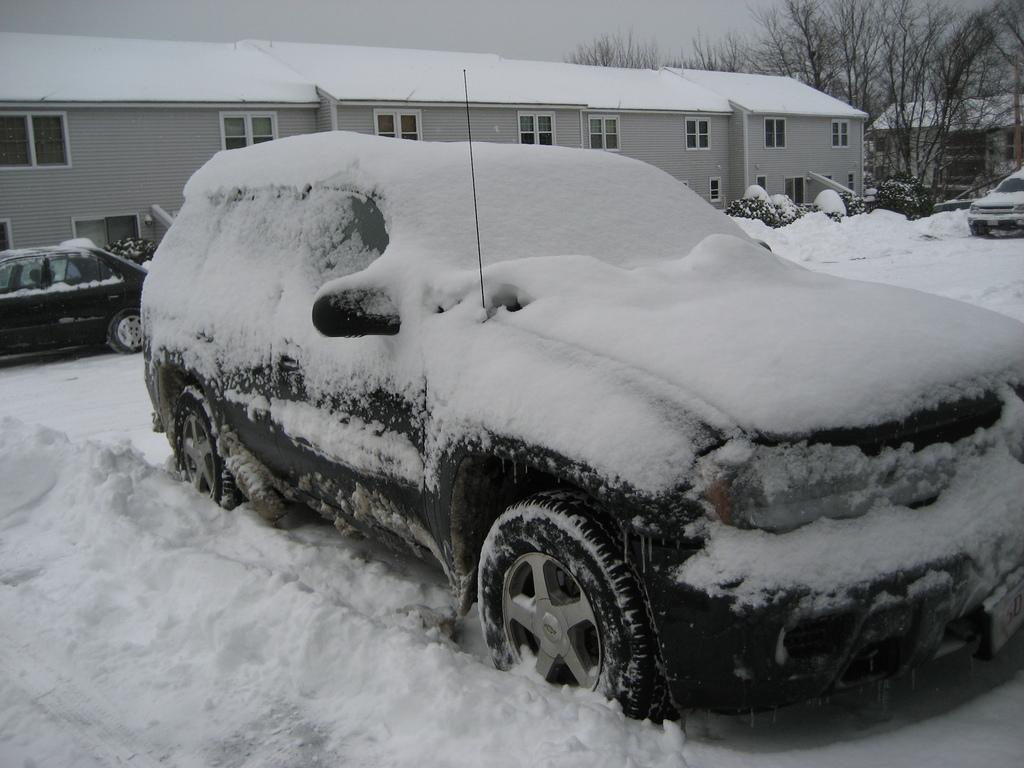What type of structures can be seen in the image? There are buildings in the image. What feature of the buildings is visible in the image? There are windows visible in the image. What type of vegetation is present in the image? Dry trees are present in the image. What else can be seen in the image besides buildings and trees? Vehicles are visible in the image. How is the vehicle depicted in the image? The vehicle is covered with snow. What is the color scheme of the image? The image is in black and white. Can you tell me how many dogs are playing with a pen in the image? There are no dogs or pens present in the image. What type of attention is the vehicle receiving in the image? There is no indication of attention being given to the vehicle in the image. 